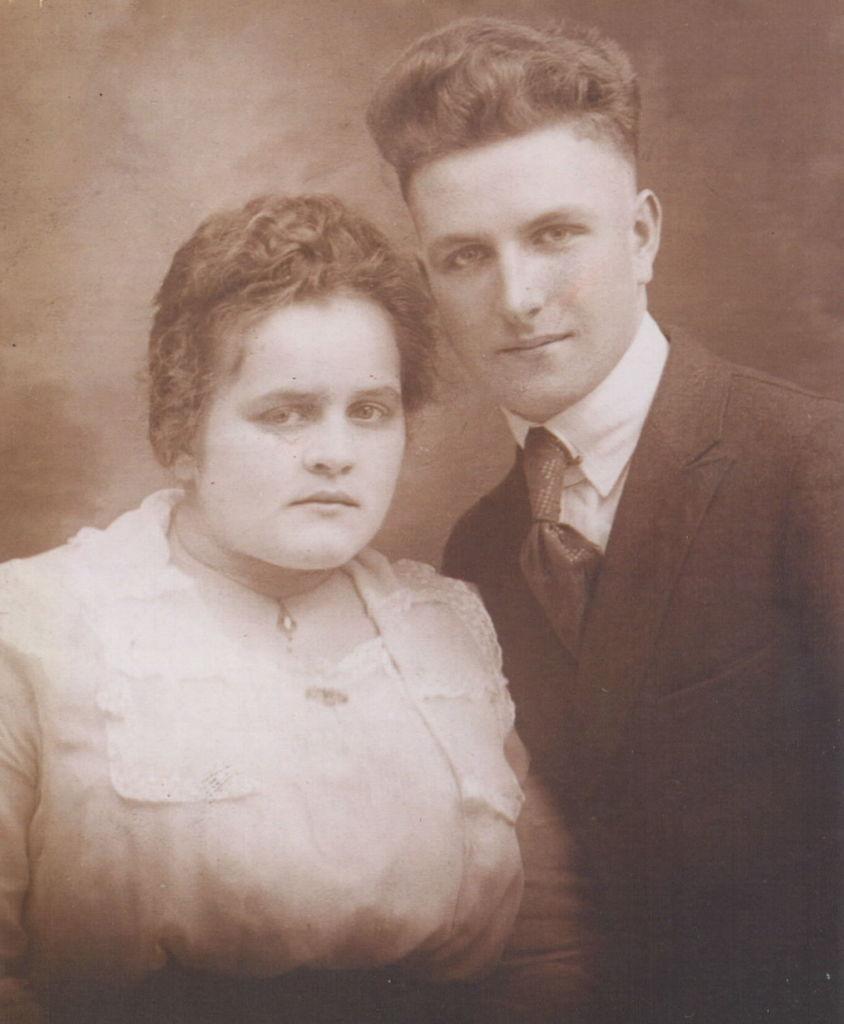How would you summarize this image in a sentence or two? In this image we can see a photo of two persons. 